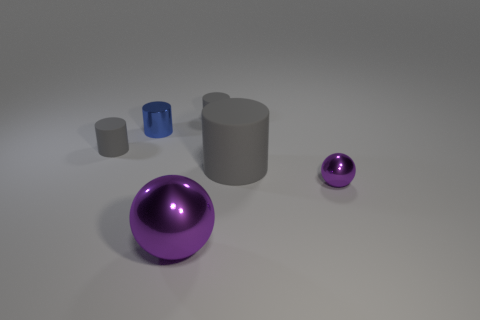Is the material of the big cylinder on the right side of the blue metal cylinder the same as the purple ball to the left of the large matte thing?
Keep it short and to the point. No. Are there an equal number of purple metallic things to the left of the small blue metal cylinder and small rubber cylinders in front of the large rubber cylinder?
Keep it short and to the point. Yes. How many things have the same color as the large shiny sphere?
Keep it short and to the point. 1. There is a large ball that is the same color as the small shiny sphere; what is it made of?
Provide a short and direct response. Metal. What number of metal things are either tiny blue cylinders or large cylinders?
Keep it short and to the point. 1. Is the shape of the tiny metal object to the left of the small purple shiny object the same as the big thing that is on the right side of the big shiny sphere?
Provide a succinct answer. Yes. There is a large purple metallic ball; what number of rubber cylinders are right of it?
Your response must be concise. 2. Is there another purple thing that has the same material as the small purple thing?
Offer a terse response. Yes. What is the material of the sphere that is the same size as the metallic cylinder?
Your response must be concise. Metal. Is the material of the small blue thing the same as the small ball?
Make the answer very short. Yes. 